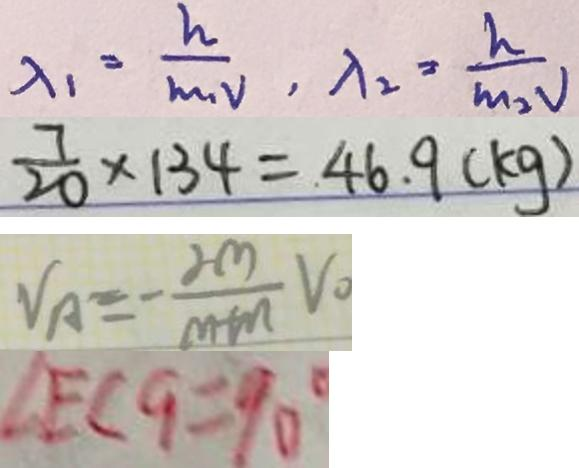<formula> <loc_0><loc_0><loc_500><loc_500>\lambda _ { 1 } = \frac { h } { m _ { 1 } v } , \lambda _ { 2 } = \frac { h } { m _ { 2 } v } 
 \frac { 7 } { 2 0 } \times 1 3 4 = 4 6 . 9 ( k g ) 
 V _ { A } = - \frac { 2 m } { m + n } V _ { 0 } 
 \angle E C G = 9 0 ^ { \circ }</formula> 